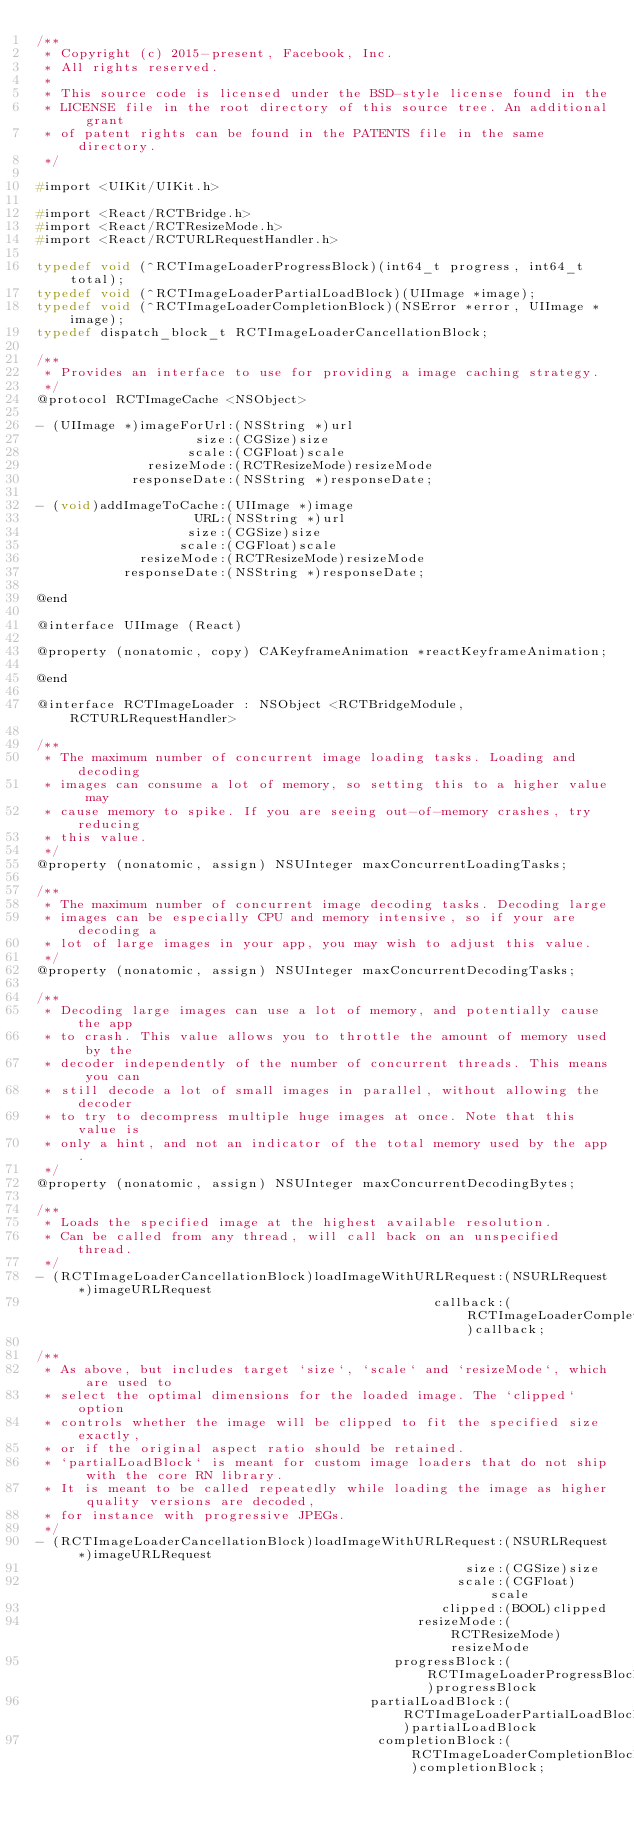<code> <loc_0><loc_0><loc_500><loc_500><_C_>/**
 * Copyright (c) 2015-present, Facebook, Inc.
 * All rights reserved.
 *
 * This source code is licensed under the BSD-style license found in the
 * LICENSE file in the root directory of this source tree. An additional grant
 * of patent rights can be found in the PATENTS file in the same directory.
 */

#import <UIKit/UIKit.h>

#import <React/RCTBridge.h>
#import <React/RCTResizeMode.h>
#import <React/RCTURLRequestHandler.h>

typedef void (^RCTImageLoaderProgressBlock)(int64_t progress, int64_t total);
typedef void (^RCTImageLoaderPartialLoadBlock)(UIImage *image);
typedef void (^RCTImageLoaderCompletionBlock)(NSError *error, UIImage *image);
typedef dispatch_block_t RCTImageLoaderCancellationBlock;

/**
 * Provides an interface to use for providing a image caching strategy.
 */
@protocol RCTImageCache <NSObject>

- (UIImage *)imageForUrl:(NSString *)url
                    size:(CGSize)size
                   scale:(CGFloat)scale
              resizeMode:(RCTResizeMode)resizeMode
            responseDate:(NSString *)responseDate;

- (void)addImageToCache:(UIImage *)image
                    URL:(NSString *)url
                   size:(CGSize)size
                  scale:(CGFloat)scale
             resizeMode:(RCTResizeMode)resizeMode
           responseDate:(NSString *)responseDate;

@end

@interface UIImage (React)

@property (nonatomic, copy) CAKeyframeAnimation *reactKeyframeAnimation;

@end

@interface RCTImageLoader : NSObject <RCTBridgeModule, RCTURLRequestHandler>

/**
 * The maximum number of concurrent image loading tasks. Loading and decoding
 * images can consume a lot of memory, so setting this to a higher value may
 * cause memory to spike. If you are seeing out-of-memory crashes, try reducing
 * this value.
 */
@property (nonatomic, assign) NSUInteger maxConcurrentLoadingTasks;

/**
 * The maximum number of concurrent image decoding tasks. Decoding large
 * images can be especially CPU and memory intensive, so if your are decoding a
 * lot of large images in your app, you may wish to adjust this value.
 */
@property (nonatomic, assign) NSUInteger maxConcurrentDecodingTasks;

/**
 * Decoding large images can use a lot of memory, and potentially cause the app
 * to crash. This value allows you to throttle the amount of memory used by the
 * decoder independently of the number of concurrent threads. This means you can
 * still decode a lot of small images in parallel, without allowing the decoder
 * to try to decompress multiple huge images at once. Note that this value is
 * only a hint, and not an indicator of the total memory used by the app.
 */
@property (nonatomic, assign) NSUInteger maxConcurrentDecodingBytes;

/**
 * Loads the specified image at the highest available resolution.
 * Can be called from any thread, will call back on an unspecified thread.
 */
- (RCTImageLoaderCancellationBlock)loadImageWithURLRequest:(NSURLRequest *)imageURLRequest
                                                  callback:(RCTImageLoaderCompletionBlock)callback;

/**
 * As above, but includes target `size`, `scale` and `resizeMode`, which are used to
 * select the optimal dimensions for the loaded image. The `clipped` option
 * controls whether the image will be clipped to fit the specified size exactly,
 * or if the original aspect ratio should be retained.
 * `partialLoadBlock` is meant for custom image loaders that do not ship with the core RN library.
 * It is meant to be called repeatedly while loading the image as higher quality versions are decoded,
 * for instance with progressive JPEGs.
 */
- (RCTImageLoaderCancellationBlock)loadImageWithURLRequest:(NSURLRequest *)imageURLRequest
                                                      size:(CGSize)size
                                                     scale:(CGFloat)scale
                                                   clipped:(BOOL)clipped
                                                resizeMode:(RCTResizeMode)resizeMode
                                             progressBlock:(RCTImageLoaderProgressBlock)progressBlock
                                          partialLoadBlock:(RCTImageLoaderPartialLoadBlock)partialLoadBlock
                                           completionBlock:(RCTImageLoaderCompletionBlock)completionBlock;
</code> 